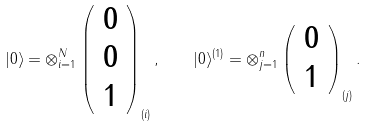<formula> <loc_0><loc_0><loc_500><loc_500>| 0 \rangle = \otimes _ { i = 1 } ^ { N } \left ( \begin{array} { c } 0 \\ 0 \\ 1 \end{array} \right ) _ { ( i ) } , \quad | 0 \rangle ^ { ( 1 ) } = \otimes _ { j = 1 } ^ { n } \left ( \begin{array} { c } 0 \\ 1 \end{array} \right ) _ { ( j ) } .</formula> 